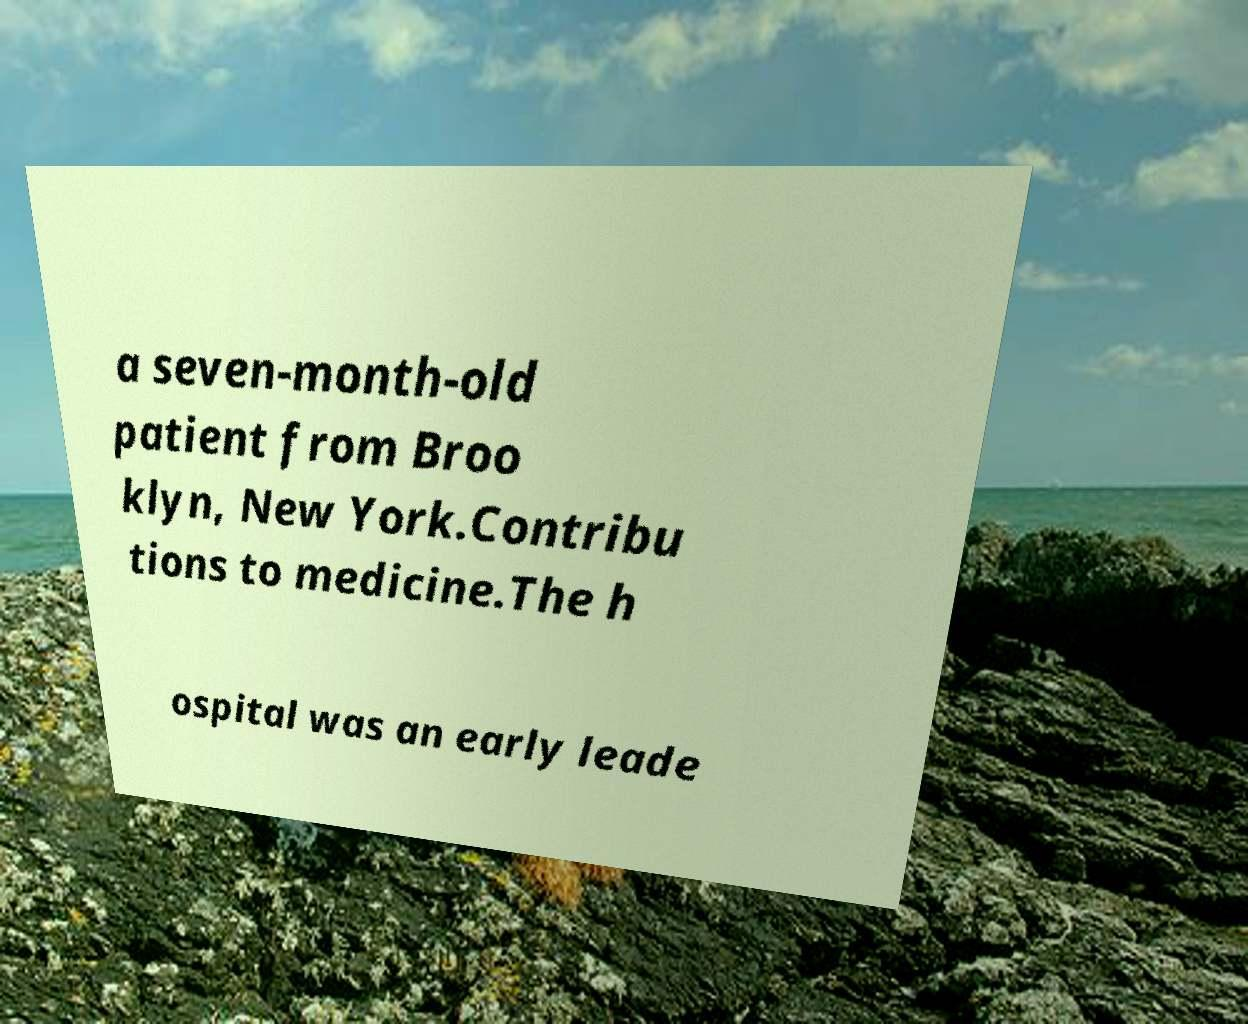There's text embedded in this image that I need extracted. Can you transcribe it verbatim? a seven-month-old patient from Broo klyn, New York.Contribu tions to medicine.The h ospital was an early leade 